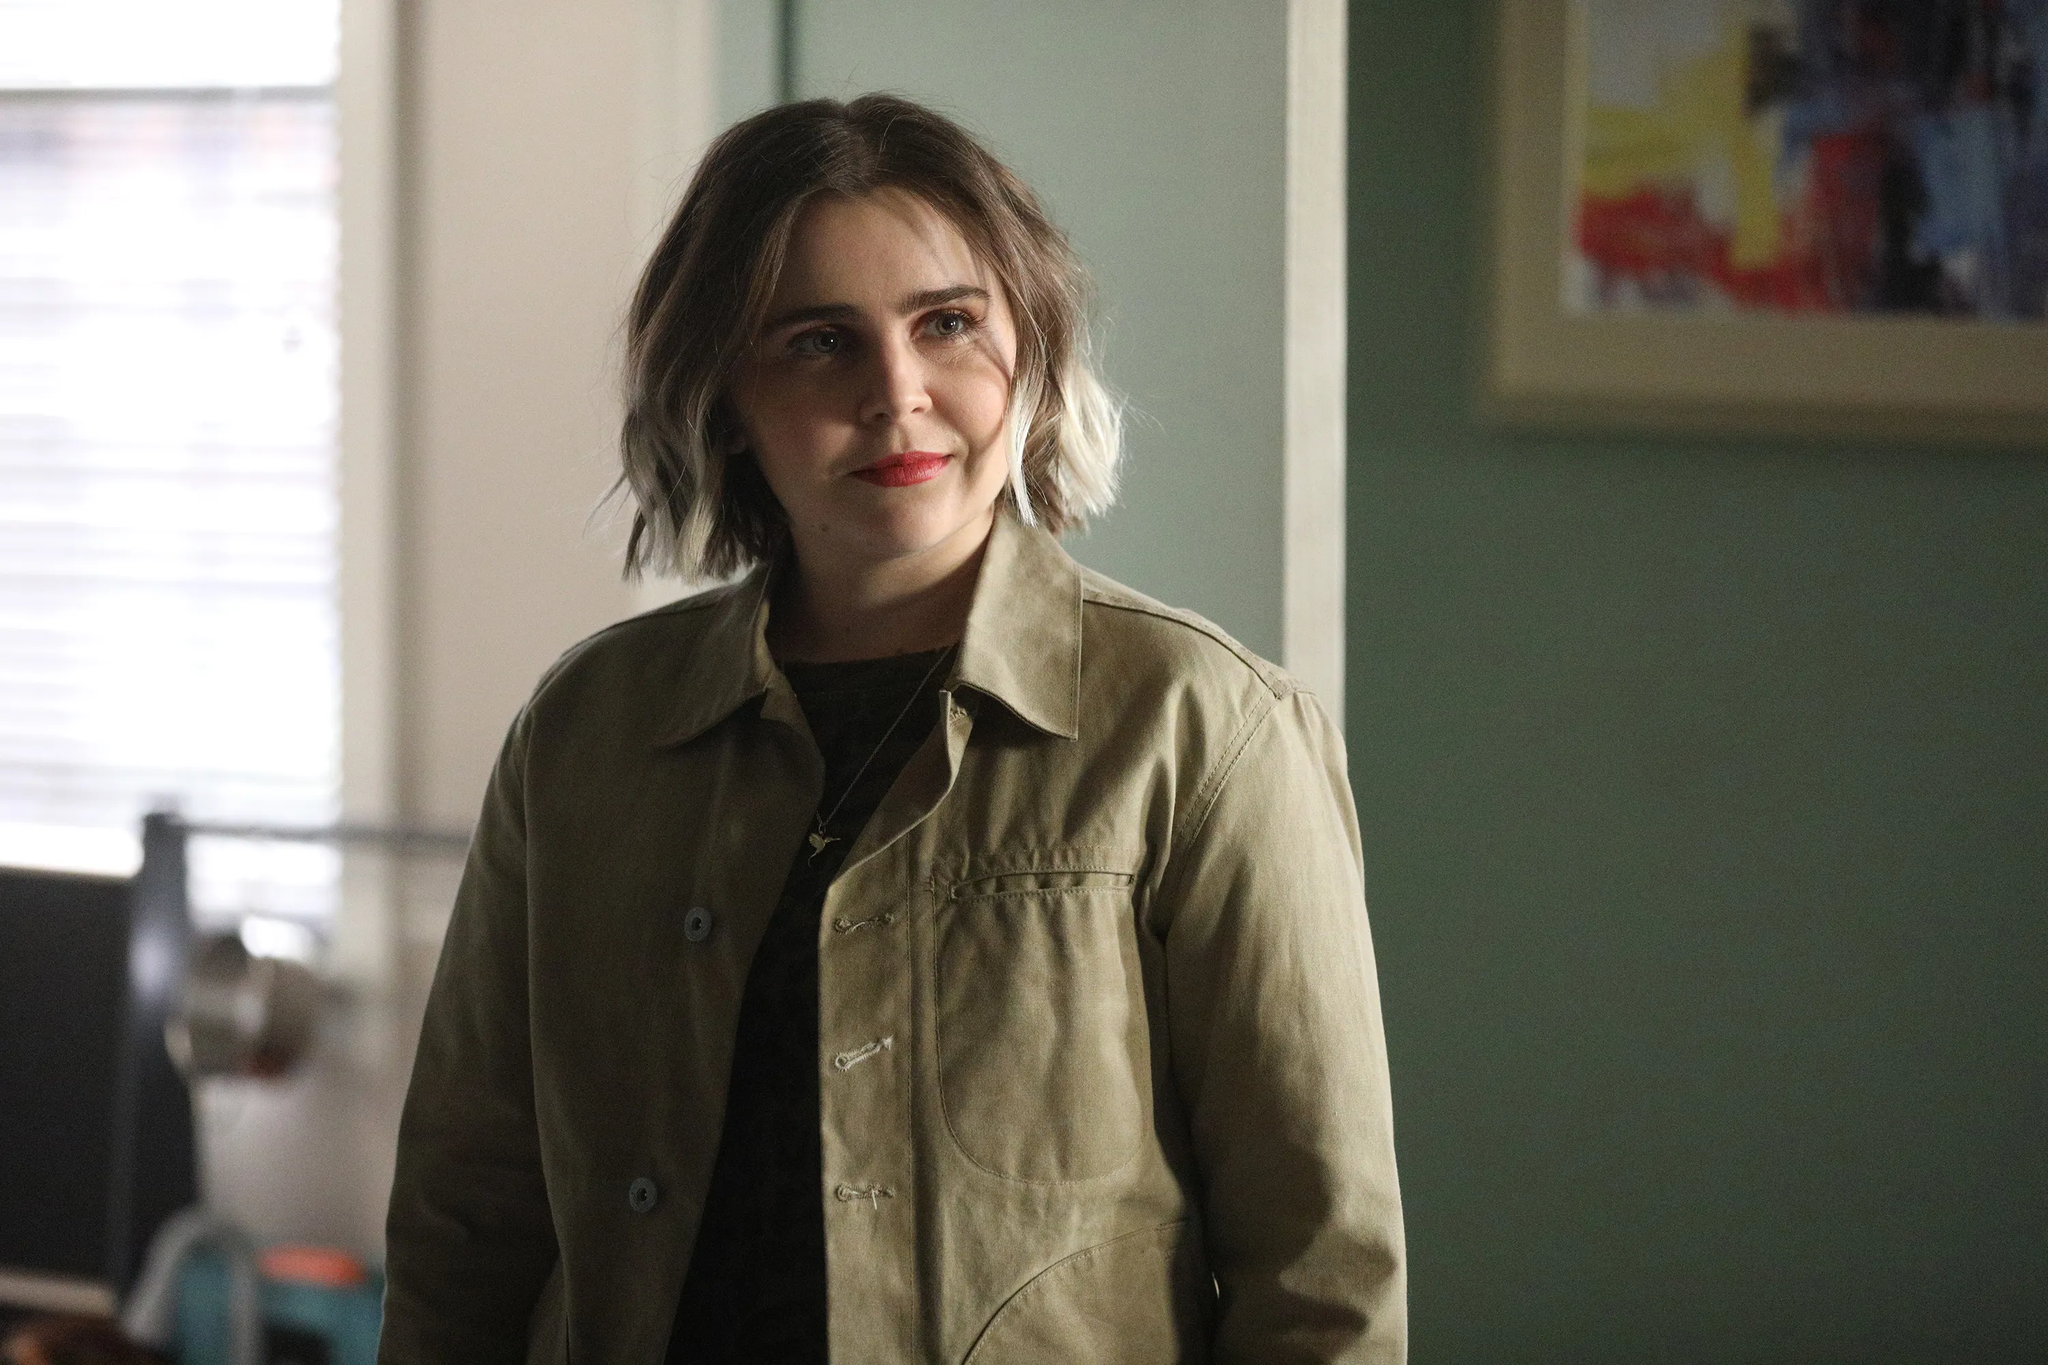What can you tell me about the character's current emotional state? The character appears to be in a calm and introspective mood. Her slight smile and the gentle direction of her gaze indicate a sense of contentment or thoughtful reflection. The cozy setting and relaxed posture further emphasize a peaceful emotional state, suggesting that she is comfortable in her surroundings and possibly reminiscing or quietly planning something. Can you describe what might have just happened before this moment? Before this moment, it's conceivable that she might have had a meaningful conversation or a quiet moment of realization. The slight smile on her face suggests a positive experience, perhaps an encounter or memory that left her feeling reflective and at ease. Given her relaxed posture, she might also have just finished some casual activity, like reading a book or talking to a friend. What kind of room does it look like she's standing in? The room appears to be a cozy living space, given its peaceful atmosphere and décor. The green wall and abstract painting suggest a touch of personal style and artistic flair. The window allows natural light to filter in, enhancing the warm and comfortable ambiance. It seems like a personal space, perhaps her living room, where she can relax and spend her leisure time. Consider the painting behind her. What kind of story could it tell? The painting behind her, with its vibrant and varied colors, might represent a rich and dynamic narrative. It could symbolize the myriad emotions and experiences one goes through in life—each color and stroke telling a different part of the story. Abstract paintings often convey feelings and moods more than concrete images, so this piece might be expressing a journey or an intense, yet beautiful, chaos of thoughts and feelings. Perhaps it was chosen to be in the room because it resonates with her personal experiences or simply brings her joy every time she looks at it. 